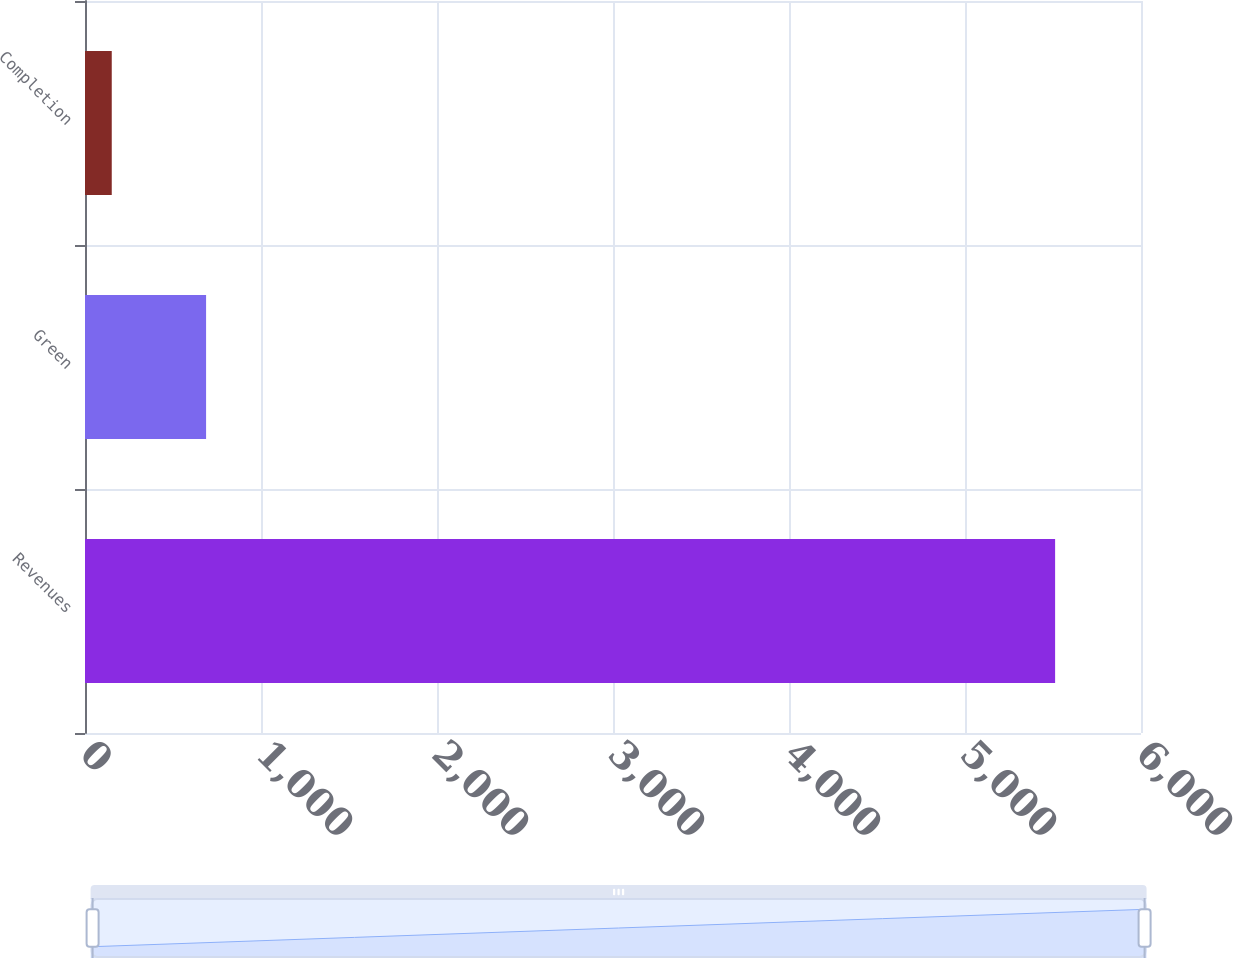<chart> <loc_0><loc_0><loc_500><loc_500><bar_chart><fcel>Revenues<fcel>Green<fcel>Completion<nl><fcel>5512<fcel>688<fcel>152<nl></chart> 